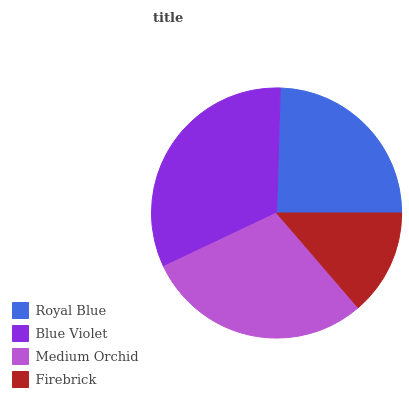Is Firebrick the minimum?
Answer yes or no. Yes. Is Blue Violet the maximum?
Answer yes or no. Yes. Is Medium Orchid the minimum?
Answer yes or no. No. Is Medium Orchid the maximum?
Answer yes or no. No. Is Blue Violet greater than Medium Orchid?
Answer yes or no. Yes. Is Medium Orchid less than Blue Violet?
Answer yes or no. Yes. Is Medium Orchid greater than Blue Violet?
Answer yes or no. No. Is Blue Violet less than Medium Orchid?
Answer yes or no. No. Is Medium Orchid the high median?
Answer yes or no. Yes. Is Royal Blue the low median?
Answer yes or no. Yes. Is Firebrick the high median?
Answer yes or no. No. Is Blue Violet the low median?
Answer yes or no. No. 